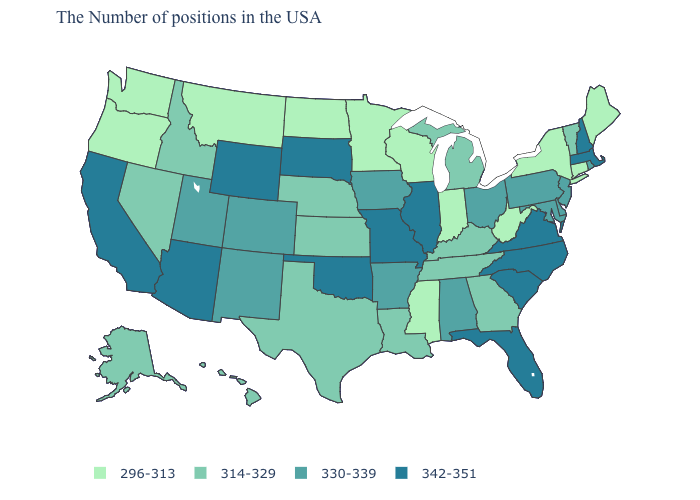Which states have the highest value in the USA?
Be succinct. Massachusetts, New Hampshire, Virginia, North Carolina, South Carolina, Florida, Illinois, Missouri, Oklahoma, South Dakota, Wyoming, Arizona, California. Which states have the highest value in the USA?
Write a very short answer. Massachusetts, New Hampshire, Virginia, North Carolina, South Carolina, Florida, Illinois, Missouri, Oklahoma, South Dakota, Wyoming, Arizona, California. Which states have the lowest value in the West?
Concise answer only. Montana, Washington, Oregon. Which states hav the highest value in the West?
Be succinct. Wyoming, Arizona, California. What is the lowest value in states that border South Carolina?
Quick response, please. 314-329. Name the states that have a value in the range 342-351?
Quick response, please. Massachusetts, New Hampshire, Virginia, North Carolina, South Carolina, Florida, Illinois, Missouri, Oklahoma, South Dakota, Wyoming, Arizona, California. Does Mississippi have a lower value than Illinois?
Quick response, please. Yes. Does South Carolina have the same value as Maine?
Concise answer only. No. How many symbols are there in the legend?
Quick response, please. 4. Does Florida have a higher value than New Jersey?
Keep it brief. Yes. What is the value of Arkansas?
Give a very brief answer. 330-339. What is the value of Arkansas?
Keep it brief. 330-339. What is the value of West Virginia?
Concise answer only. 296-313. What is the value of Rhode Island?
Short answer required. 330-339. How many symbols are there in the legend?
Keep it brief. 4. 